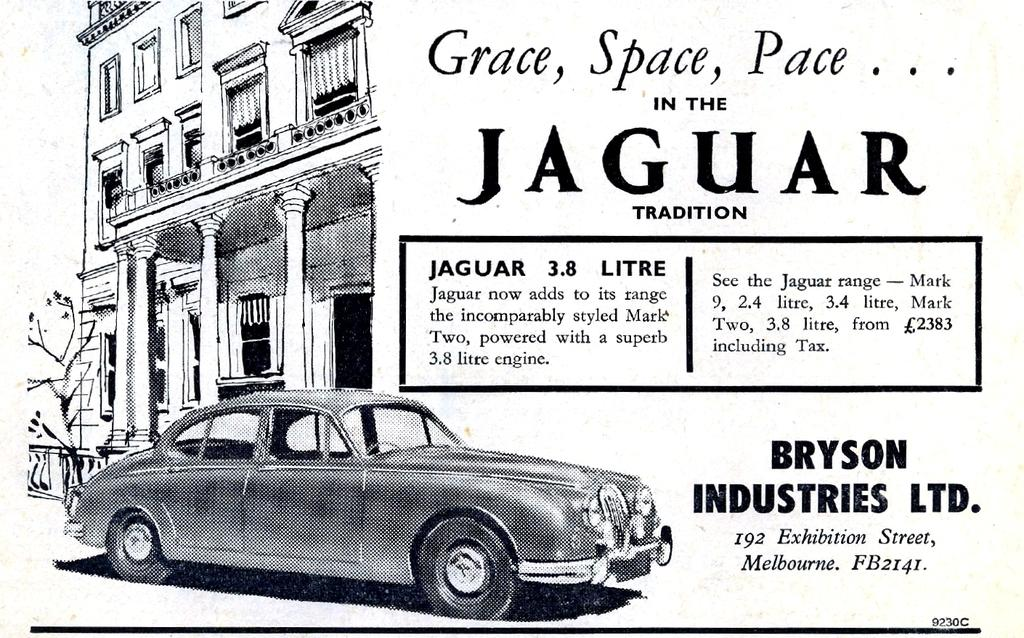What type of visual is the image? The image is a poster. What is depicted on the poster? There is a depiction of a car and a building on the poster. Are there any words on the poster? Yes, there is text on the poster. Can you see any clouds in the image? There are no clouds visible in the image, as it is a poster with a depiction of a car and a building. What type of wish is being granted in the image? There is no mention of a wish being granted in the image, as it is a poster with a depiction of a car and a building. 